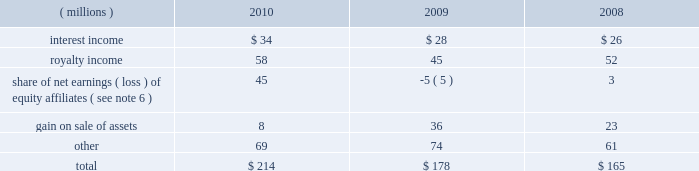Notes to the consolidated financial statements related to the change in the unrealized gain ( loss ) on derivatives for the years ended december 31 , 2010 , 2009 and 2008 was $ 1 million , $ ( 16 ) million and $ 30 million , respectively .
19 .
Employee savings plan ppg 2019s employee savings plan ( 201csavings plan 201d ) covers substantially all u.s .
Employees .
The company makes matching contributions to the savings plan based upon participants 2019 savings , subject to certain limitations .
For most participants not covered by a collective bargaining agreement , company-matching contributions are established each year at the discretion of the company and are applied to a maximum of 6% ( 6 % ) of eligible participant compensation .
For those participants whose employment is covered by a collective bargaining agreement , the level of company- matching contribution , if any , is determined by the collective bargaining agreement .
The company-matching contribution was 100% ( 100 % ) for 2008 and for the first two months of 2009 .
The company- matching contribution was suspended from march 2009 through june 2010 as a cost savings measure in recognition of the adverse impact of the global recession .
Effective july 1 , 2010 , the company match was reinstated at 50% ( 50 % ) on the first 6% ( 6 % ) contributed for most employees eligible for the company-matching contribution feature .
This would have included the bargained employees in accordance with their collective bargaining agreements .
On january 1 , 2011 , the company match was increased to 75% ( 75 % ) on the first 6% ( 6 % ) contributed by these eligible employees .
Compensation expense and cash contributions related to the company match of participant contributions to the savings plan for 2010 , 2009 and 2008 totaled $ 9 million , $ 7 million and $ 42 million , respectively .
A portion of the savings plan qualifies under the internal revenue code as an employee stock ownership plan .
As a result , the tax deductible dividends on ppg shares held by the savings plan were $ 24 million , $ 28 million and $ 29 million for 2010 , 2009 and 2008 , respectively .
20 .
Other earnings ( millions ) 2010 2009 2008 .
Total $ 214 $ 178 $ 165 21 .
Stock-based compensation the company 2019s stock-based compensation includes stock options , restricted stock units ( 201crsus 201d ) and grants of contingent shares that are earned based on achieving targeted levels of total shareholder return .
All current grants of stock options , rsus and contingent shares are made under the ppg industries , inc .
Omnibus incentive plan ( 201cppg omnibus plan 201d ) .
Shares available for future grants under the ppg omnibus plan were 4.1 million as of december 31 , 2010 .
Total stock-based compensation cost was $ 52 million , $ 34 million and $ 33 million in 2010 , 2009 and 2008 , respectively .
The total income tax benefit recognized in the accompanying consolidated statement of income related to the stock-based compensation was $ 18 million , $ 12 million and $ 12 million in 2010 , 2009 and 2008 , respectively .
Stock options ppg has outstanding stock option awards that have been granted under two stock option plans : the ppg industries , inc .
Stock plan ( 201cppg stock plan 201d ) and the ppg omnibus plan .
Under the ppg omnibus plan and the ppg stock plan , certain employees of the company have been granted options to purchase shares of common stock at prices equal to the fair market value of the shares on the date the options were granted .
The options are generally exercisable beginning from six to 48 months after being granted and have a maximum term of 10 years .
Upon exercise of a stock option , shares of company stock are issued from treasury stock .
The ppg stock plan includes a restored option provision for options originally granted prior to january 1 , 2003 that allows an optionee to exercise options and satisfy the option price by certifying ownership of mature shares of ppg common stock with equivalent market value .
The fair value of stock options issued to employees is measured on the date of grant and is recognized as expense over the requisite service period .
Ppg estimates the fair value of stock options using the black-scholes option pricing model .
The risk-free interest rate is determined by using the u.s .
Treasury yield curve at the date of the grant and using a maturity equal to the expected life of the option .
The expected life of options is calculated using the average of the vesting term and the maximum term , as prescribed by accounting guidance on the use of the simplified method for determining the expected term of an employee share option .
This method is used as the vesting term of stock options was changed to three years in 2004 and , as a result , the historical exercise data does not provide a reasonable basis upon which to estimate the expected life of options .
The expected dividend yield and volatility are based on historical stock prices and dividend amounts over past time periods equal in length to the expected life of the options .
66 2010 ppg annual report and form 10-k .
Interest income is what percent of other income for 2010?\\n\\n? 
Computations: (34 / 214)
Answer: 0.15888. Notes to the consolidated financial statements related to the change in the unrealized gain ( loss ) on derivatives for the years ended december 31 , 2010 , 2009 and 2008 was $ 1 million , $ ( 16 ) million and $ 30 million , respectively .
19 .
Employee savings plan ppg 2019s employee savings plan ( 201csavings plan 201d ) covers substantially all u.s .
Employees .
The company makes matching contributions to the savings plan based upon participants 2019 savings , subject to certain limitations .
For most participants not covered by a collective bargaining agreement , company-matching contributions are established each year at the discretion of the company and are applied to a maximum of 6% ( 6 % ) of eligible participant compensation .
For those participants whose employment is covered by a collective bargaining agreement , the level of company- matching contribution , if any , is determined by the collective bargaining agreement .
The company-matching contribution was 100% ( 100 % ) for 2008 and for the first two months of 2009 .
The company- matching contribution was suspended from march 2009 through june 2010 as a cost savings measure in recognition of the adverse impact of the global recession .
Effective july 1 , 2010 , the company match was reinstated at 50% ( 50 % ) on the first 6% ( 6 % ) contributed for most employees eligible for the company-matching contribution feature .
This would have included the bargained employees in accordance with their collective bargaining agreements .
On january 1 , 2011 , the company match was increased to 75% ( 75 % ) on the first 6% ( 6 % ) contributed by these eligible employees .
Compensation expense and cash contributions related to the company match of participant contributions to the savings plan for 2010 , 2009 and 2008 totaled $ 9 million , $ 7 million and $ 42 million , respectively .
A portion of the savings plan qualifies under the internal revenue code as an employee stock ownership plan .
As a result , the tax deductible dividends on ppg shares held by the savings plan were $ 24 million , $ 28 million and $ 29 million for 2010 , 2009 and 2008 , respectively .
20 .
Other earnings ( millions ) 2010 2009 2008 .
Total $ 214 $ 178 $ 165 21 .
Stock-based compensation the company 2019s stock-based compensation includes stock options , restricted stock units ( 201crsus 201d ) and grants of contingent shares that are earned based on achieving targeted levels of total shareholder return .
All current grants of stock options , rsus and contingent shares are made under the ppg industries , inc .
Omnibus incentive plan ( 201cppg omnibus plan 201d ) .
Shares available for future grants under the ppg omnibus plan were 4.1 million as of december 31 , 2010 .
Total stock-based compensation cost was $ 52 million , $ 34 million and $ 33 million in 2010 , 2009 and 2008 , respectively .
The total income tax benefit recognized in the accompanying consolidated statement of income related to the stock-based compensation was $ 18 million , $ 12 million and $ 12 million in 2010 , 2009 and 2008 , respectively .
Stock options ppg has outstanding stock option awards that have been granted under two stock option plans : the ppg industries , inc .
Stock plan ( 201cppg stock plan 201d ) and the ppg omnibus plan .
Under the ppg omnibus plan and the ppg stock plan , certain employees of the company have been granted options to purchase shares of common stock at prices equal to the fair market value of the shares on the date the options were granted .
The options are generally exercisable beginning from six to 48 months after being granted and have a maximum term of 10 years .
Upon exercise of a stock option , shares of company stock are issued from treasury stock .
The ppg stock plan includes a restored option provision for options originally granted prior to january 1 , 2003 that allows an optionee to exercise options and satisfy the option price by certifying ownership of mature shares of ppg common stock with equivalent market value .
The fair value of stock options issued to employees is measured on the date of grant and is recognized as expense over the requisite service period .
Ppg estimates the fair value of stock options using the black-scholes option pricing model .
The risk-free interest rate is determined by using the u.s .
Treasury yield curve at the date of the grant and using a maturity equal to the expected life of the option .
The expected life of options is calculated using the average of the vesting term and the maximum term , as prescribed by accounting guidance on the use of the simplified method for determining the expected term of an employee share option .
This method is used as the vesting term of stock options was changed to three years in 2004 and , as a result , the historical exercise data does not provide a reasonable basis upon which to estimate the expected life of options .
The expected dividend yield and volatility are based on historical stock prices and dividend amounts over past time periods equal in length to the expected life of the options .
66 2010 ppg annual report and form 10-k .
Was interest income greater than stock-based compensation cost in 2010? 
Computations: (34 > 52)
Answer: no. Notes to the consolidated financial statements related to the change in the unrealized gain ( loss ) on derivatives for the years ended december 31 , 2010 , 2009 and 2008 was $ 1 million , $ ( 16 ) million and $ 30 million , respectively .
19 .
Employee savings plan ppg 2019s employee savings plan ( 201csavings plan 201d ) covers substantially all u.s .
Employees .
The company makes matching contributions to the savings plan based upon participants 2019 savings , subject to certain limitations .
For most participants not covered by a collective bargaining agreement , company-matching contributions are established each year at the discretion of the company and are applied to a maximum of 6% ( 6 % ) of eligible participant compensation .
For those participants whose employment is covered by a collective bargaining agreement , the level of company- matching contribution , if any , is determined by the collective bargaining agreement .
The company-matching contribution was 100% ( 100 % ) for 2008 and for the first two months of 2009 .
The company- matching contribution was suspended from march 2009 through june 2010 as a cost savings measure in recognition of the adverse impact of the global recession .
Effective july 1 , 2010 , the company match was reinstated at 50% ( 50 % ) on the first 6% ( 6 % ) contributed for most employees eligible for the company-matching contribution feature .
This would have included the bargained employees in accordance with their collective bargaining agreements .
On january 1 , 2011 , the company match was increased to 75% ( 75 % ) on the first 6% ( 6 % ) contributed by these eligible employees .
Compensation expense and cash contributions related to the company match of participant contributions to the savings plan for 2010 , 2009 and 2008 totaled $ 9 million , $ 7 million and $ 42 million , respectively .
A portion of the savings plan qualifies under the internal revenue code as an employee stock ownership plan .
As a result , the tax deductible dividends on ppg shares held by the savings plan were $ 24 million , $ 28 million and $ 29 million for 2010 , 2009 and 2008 , respectively .
20 .
Other earnings ( millions ) 2010 2009 2008 .
Total $ 214 $ 178 $ 165 21 .
Stock-based compensation the company 2019s stock-based compensation includes stock options , restricted stock units ( 201crsus 201d ) and grants of contingent shares that are earned based on achieving targeted levels of total shareholder return .
All current grants of stock options , rsus and contingent shares are made under the ppg industries , inc .
Omnibus incentive plan ( 201cppg omnibus plan 201d ) .
Shares available for future grants under the ppg omnibus plan were 4.1 million as of december 31 , 2010 .
Total stock-based compensation cost was $ 52 million , $ 34 million and $ 33 million in 2010 , 2009 and 2008 , respectively .
The total income tax benefit recognized in the accompanying consolidated statement of income related to the stock-based compensation was $ 18 million , $ 12 million and $ 12 million in 2010 , 2009 and 2008 , respectively .
Stock options ppg has outstanding stock option awards that have been granted under two stock option plans : the ppg industries , inc .
Stock plan ( 201cppg stock plan 201d ) and the ppg omnibus plan .
Under the ppg omnibus plan and the ppg stock plan , certain employees of the company have been granted options to purchase shares of common stock at prices equal to the fair market value of the shares on the date the options were granted .
The options are generally exercisable beginning from six to 48 months after being granted and have a maximum term of 10 years .
Upon exercise of a stock option , shares of company stock are issued from treasury stock .
The ppg stock plan includes a restored option provision for options originally granted prior to january 1 , 2003 that allows an optionee to exercise options and satisfy the option price by certifying ownership of mature shares of ppg common stock with equivalent market value .
The fair value of stock options issued to employees is measured on the date of grant and is recognized as expense over the requisite service period .
Ppg estimates the fair value of stock options using the black-scholes option pricing model .
The risk-free interest rate is determined by using the u.s .
Treasury yield curve at the date of the grant and using a maturity equal to the expected life of the option .
The expected life of options is calculated using the average of the vesting term and the maximum term , as prescribed by accounting guidance on the use of the simplified method for determining the expected term of an employee share option .
This method is used as the vesting term of stock options was changed to three years in 2004 and , as a result , the historical exercise data does not provide a reasonable basis upon which to estimate the expected life of options .
The expected dividend yield and volatility are based on historical stock prices and dividend amounts over past time periods equal in length to the expected life of the options .
66 2010 ppg annual report and form 10-k .
What was the change in millions of total other earnings from 2008 to 2009? 
Computations: (178 - 165)
Answer: 13.0. Notes to the consolidated financial statements related to the change in the unrealized gain ( loss ) on derivatives for the years ended december 31 , 2010 , 2009 and 2008 was $ 1 million , $ ( 16 ) million and $ 30 million , respectively .
19 .
Employee savings plan ppg 2019s employee savings plan ( 201csavings plan 201d ) covers substantially all u.s .
Employees .
The company makes matching contributions to the savings plan based upon participants 2019 savings , subject to certain limitations .
For most participants not covered by a collective bargaining agreement , company-matching contributions are established each year at the discretion of the company and are applied to a maximum of 6% ( 6 % ) of eligible participant compensation .
For those participants whose employment is covered by a collective bargaining agreement , the level of company- matching contribution , if any , is determined by the collective bargaining agreement .
The company-matching contribution was 100% ( 100 % ) for 2008 and for the first two months of 2009 .
The company- matching contribution was suspended from march 2009 through june 2010 as a cost savings measure in recognition of the adverse impact of the global recession .
Effective july 1 , 2010 , the company match was reinstated at 50% ( 50 % ) on the first 6% ( 6 % ) contributed for most employees eligible for the company-matching contribution feature .
This would have included the bargained employees in accordance with their collective bargaining agreements .
On january 1 , 2011 , the company match was increased to 75% ( 75 % ) on the first 6% ( 6 % ) contributed by these eligible employees .
Compensation expense and cash contributions related to the company match of participant contributions to the savings plan for 2010 , 2009 and 2008 totaled $ 9 million , $ 7 million and $ 42 million , respectively .
A portion of the savings plan qualifies under the internal revenue code as an employee stock ownership plan .
As a result , the tax deductible dividends on ppg shares held by the savings plan were $ 24 million , $ 28 million and $ 29 million for 2010 , 2009 and 2008 , respectively .
20 .
Other earnings ( millions ) 2010 2009 2008 .
Total $ 214 $ 178 $ 165 21 .
Stock-based compensation the company 2019s stock-based compensation includes stock options , restricted stock units ( 201crsus 201d ) and grants of contingent shares that are earned based on achieving targeted levels of total shareholder return .
All current grants of stock options , rsus and contingent shares are made under the ppg industries , inc .
Omnibus incentive plan ( 201cppg omnibus plan 201d ) .
Shares available for future grants under the ppg omnibus plan were 4.1 million as of december 31 , 2010 .
Total stock-based compensation cost was $ 52 million , $ 34 million and $ 33 million in 2010 , 2009 and 2008 , respectively .
The total income tax benefit recognized in the accompanying consolidated statement of income related to the stock-based compensation was $ 18 million , $ 12 million and $ 12 million in 2010 , 2009 and 2008 , respectively .
Stock options ppg has outstanding stock option awards that have been granted under two stock option plans : the ppg industries , inc .
Stock plan ( 201cppg stock plan 201d ) and the ppg omnibus plan .
Under the ppg omnibus plan and the ppg stock plan , certain employees of the company have been granted options to purchase shares of common stock at prices equal to the fair market value of the shares on the date the options were granted .
The options are generally exercisable beginning from six to 48 months after being granted and have a maximum term of 10 years .
Upon exercise of a stock option , shares of company stock are issued from treasury stock .
The ppg stock plan includes a restored option provision for options originally granted prior to january 1 , 2003 that allows an optionee to exercise options and satisfy the option price by certifying ownership of mature shares of ppg common stock with equivalent market value .
The fair value of stock options issued to employees is measured on the date of grant and is recognized as expense over the requisite service period .
Ppg estimates the fair value of stock options using the black-scholes option pricing model .
The risk-free interest rate is determined by using the u.s .
Treasury yield curve at the date of the grant and using a maturity equal to the expected life of the option .
The expected life of options is calculated using the average of the vesting term and the maximum term , as prescribed by accounting guidance on the use of the simplified method for determining the expected term of an employee share option .
This method is used as the vesting term of stock options was changed to three years in 2004 and , as a result , the historical exercise data does not provide a reasonable basis upon which to estimate the expected life of options .
The expected dividend yield and volatility are based on historical stock prices and dividend amounts over past time periods equal in length to the expected life of the options .
66 2010 ppg annual report and form 10-k .
What was the change in millions of total other earnings from 2009 to 2010? 
Computations: (214 - 178)
Answer: 36.0. 